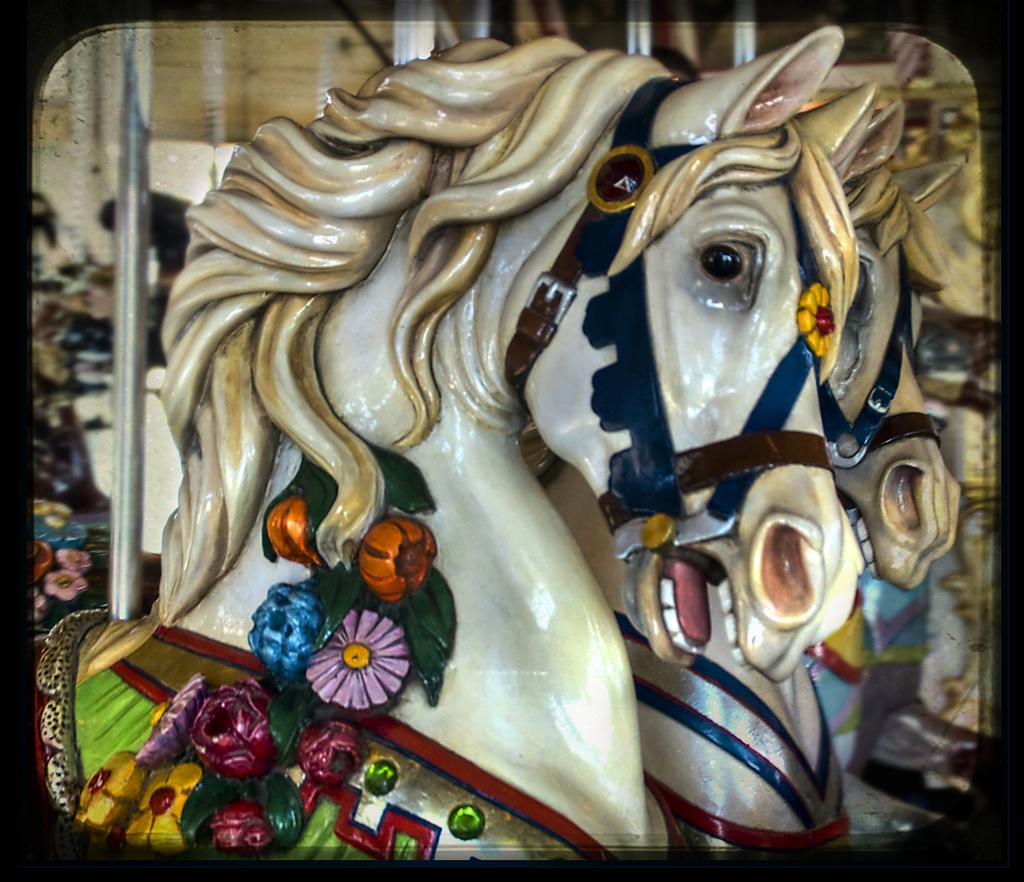What is the main subject of the image? There is a statue of a horse in the image. Can you describe any other objects or features in the background? There is a mirror in the background of the image. What type of society is depicted in the image? There is no society depicted in the image; it features a statue of a horse and a mirror. What kind of chain is attached to the horse's legs in the image? There is no chain present in the image; it only shows a statue of a horse and a mirror. 